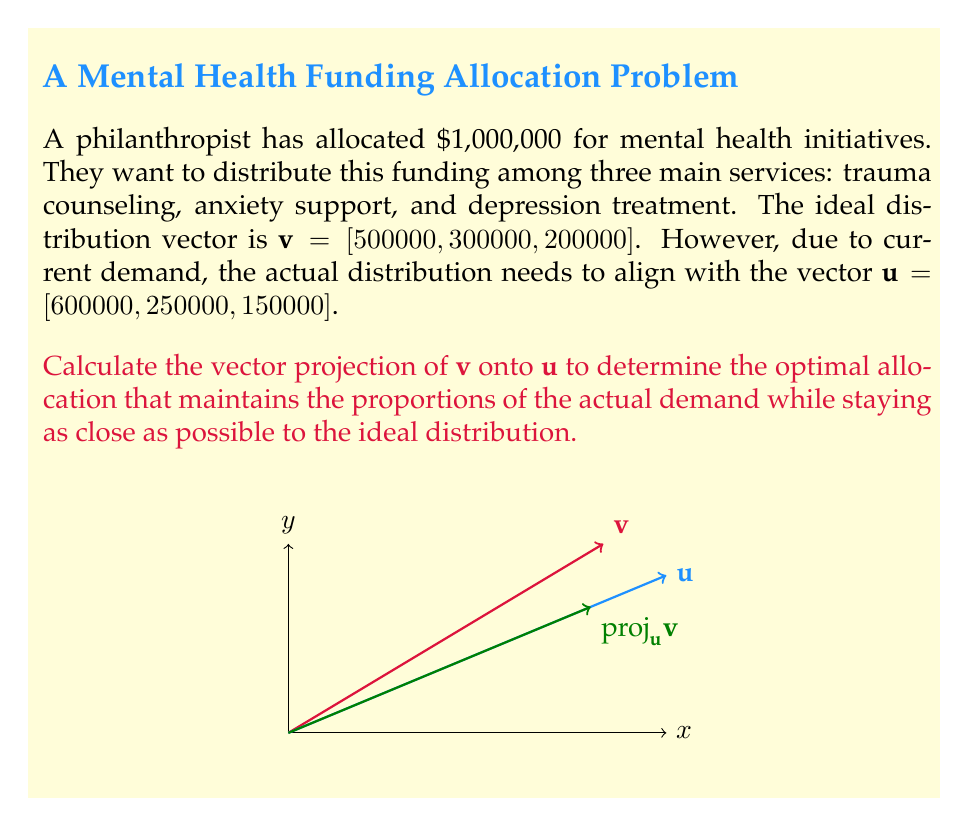Give your solution to this math problem. To find the vector projection of $\mathbf{v}$ onto $\mathbf{u}$, we'll use the formula:

$$\text{proj}_\mathbf{u}\mathbf{v} = \frac{\mathbf{v} \cdot \mathbf{u}}{\|\mathbf{u}\|^2} \mathbf{u}$$

Step 1: Calculate the dot product $\mathbf{v} \cdot \mathbf{u}$
$$\mathbf{v} \cdot \mathbf{u} = 500000 \cdot 600000 + 300000 \cdot 250000 + 200000 \cdot 150000 = 3.775 \times 10^{11}$$

Step 2: Calculate $\|\mathbf{u}\|^2$
$$\|\mathbf{u}\|^2 = 600000^2 + 250000^2 + 150000^2 = 4.4125 \times 10^{11}$$

Step 3: Calculate the scalar projection
$$\frac{\mathbf{v} \cdot \mathbf{u}}{\|\mathbf{u}\|^2} = \frac{3.775 \times 10^{11}}{4.4125 \times 10^{11} } \approx 0.8555$$

Step 4: Multiply the scalar projection by $\mathbf{u}$ to get the vector projection
$$\text{proj}_\mathbf{u}\mathbf{v} = 0.8555 \cdot [600000, 250000, 150000]$$
$$\text{proj}_\mathbf{u}\mathbf{v} \approx [513300, 213875, 128325]$$

This result represents the optimal allocation that maintains the proportions of the actual demand while staying as close as possible to the ideal distribution.
Answer: $[513300, 213875, 128325]$ 